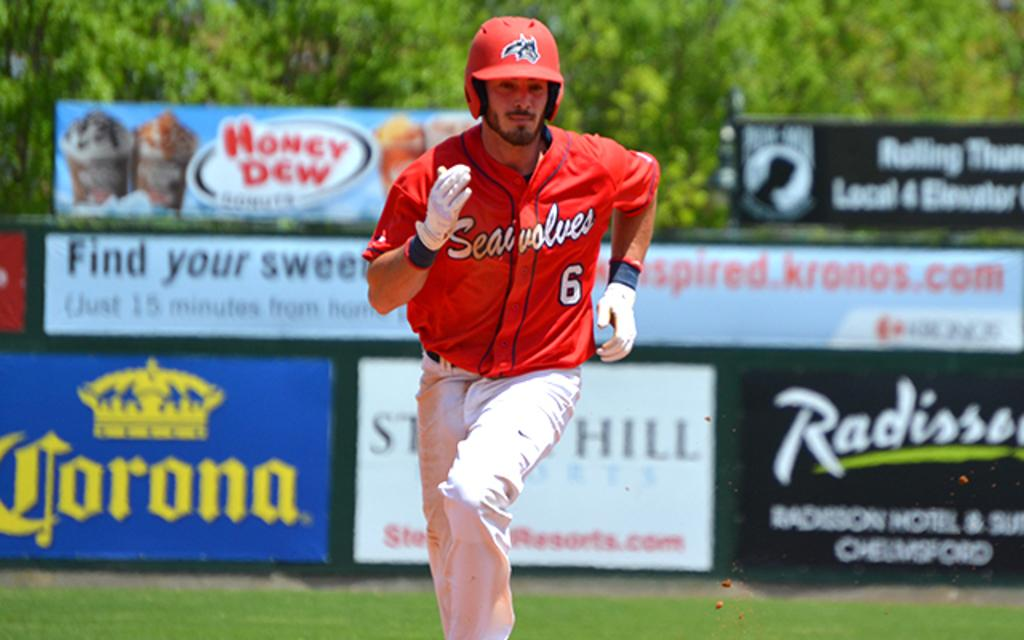Provide a one-sentence caption for the provided image. a Seawolves baseball player running to the base with Corona being one of the adverts in the background. 